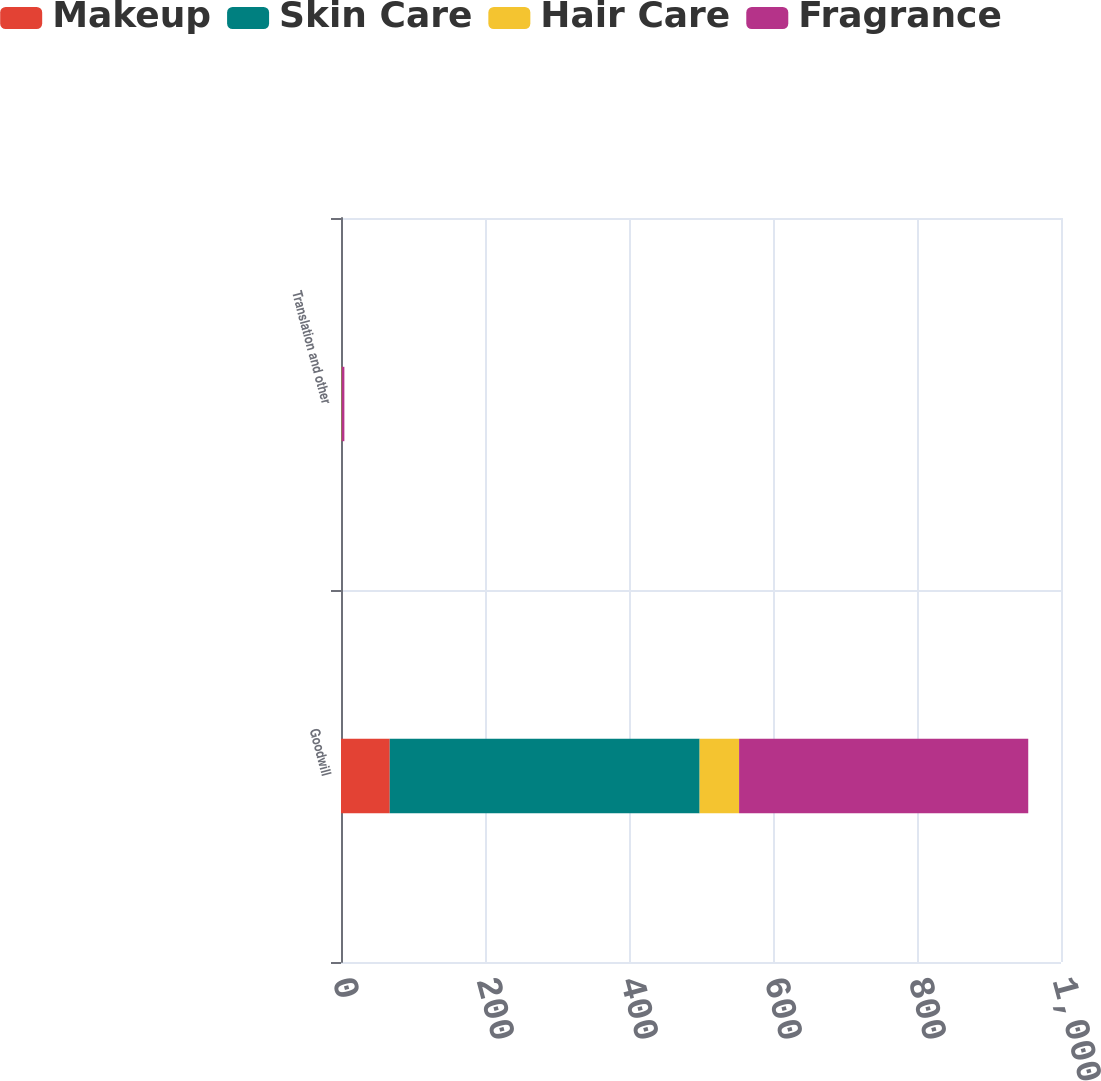Convert chart to OTSL. <chart><loc_0><loc_0><loc_500><loc_500><stacked_bar_chart><ecel><fcel>Goodwill<fcel>Translation and other<nl><fcel>Makeup<fcel>67.7<fcel>0.6<nl><fcel>Skin Care<fcel>430.4<fcel>0.4<nl><fcel>Hair Care<fcel>54.8<fcel>0.3<nl><fcel>Fragrance<fcel>401.6<fcel>3.4<nl></chart> 